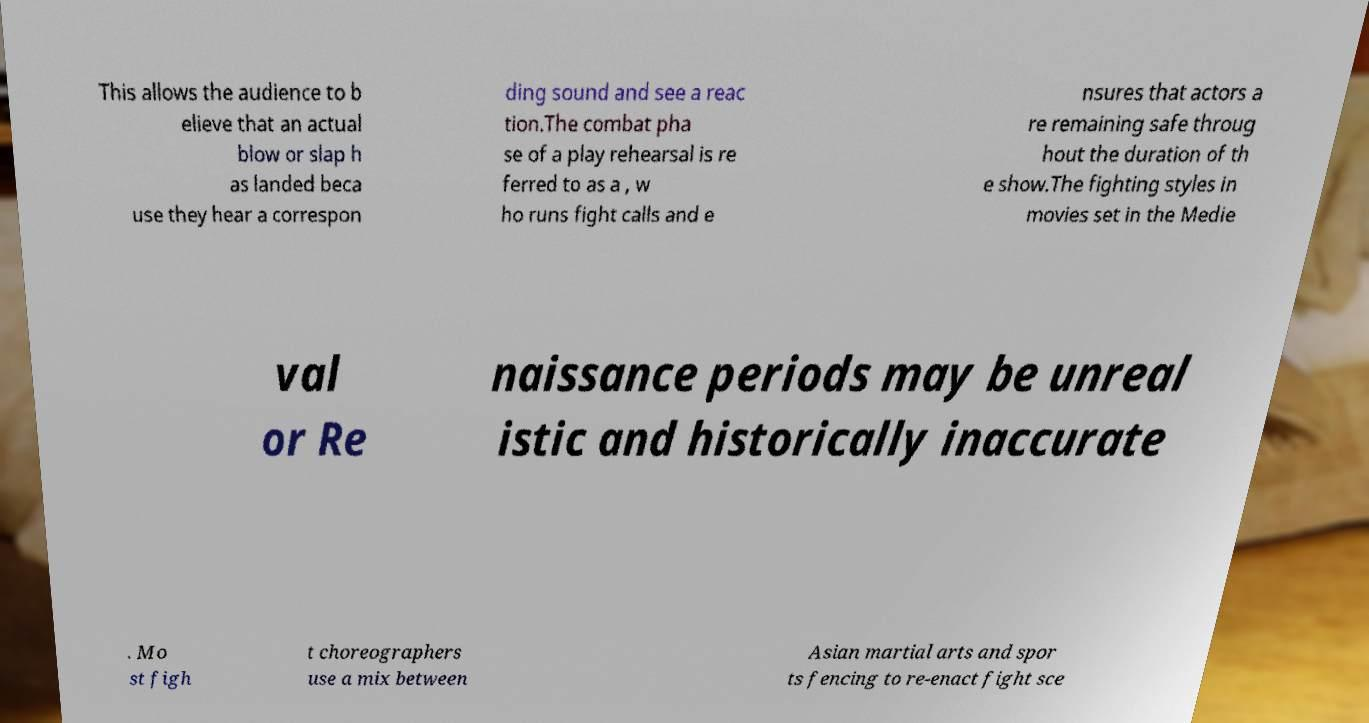Can you read and provide the text displayed in the image?This photo seems to have some interesting text. Can you extract and type it out for me? This allows the audience to b elieve that an actual blow or slap h as landed beca use they hear a correspon ding sound and see a reac tion.The combat pha se of a play rehearsal is re ferred to as a , w ho runs fight calls and e nsures that actors a re remaining safe throug hout the duration of th e show.The fighting styles in movies set in the Medie val or Re naissance periods may be unreal istic and historically inaccurate . Mo st figh t choreographers use a mix between Asian martial arts and spor ts fencing to re-enact fight sce 